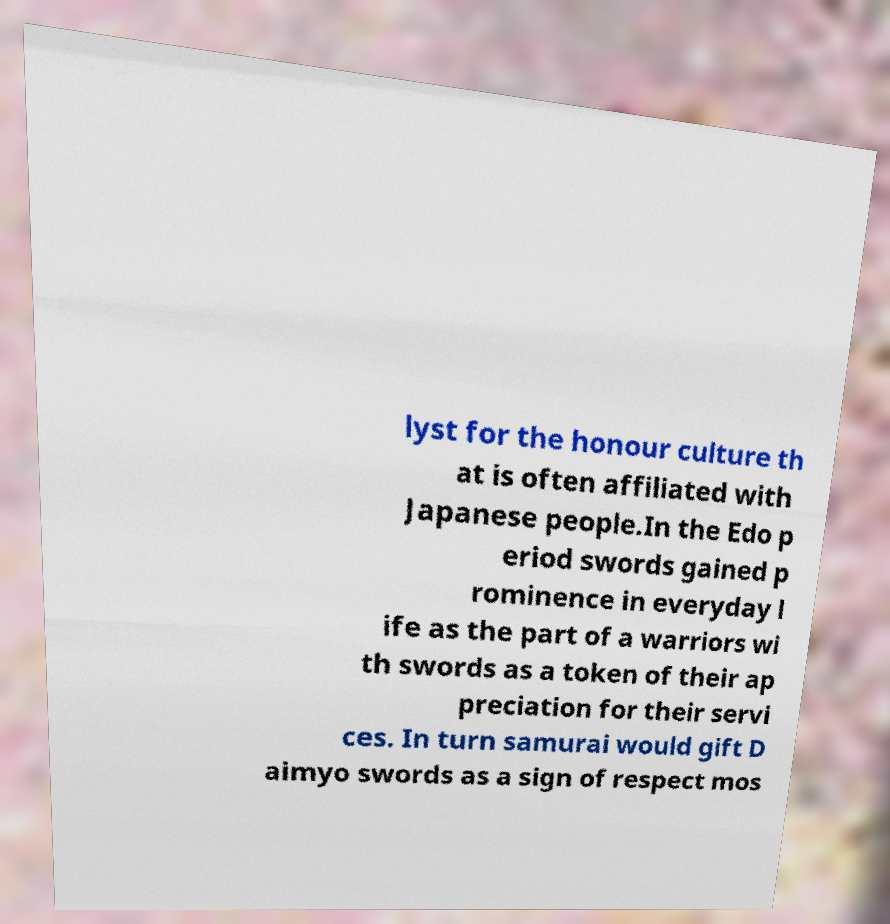Can you read and provide the text displayed in the image?This photo seems to have some interesting text. Can you extract and type it out for me? lyst for the honour culture th at is often affiliated with Japanese people.In the Edo p eriod swords gained p rominence in everyday l ife as the part of a warriors wi th swords as a token of their ap preciation for their servi ces. In turn samurai would gift D aimyo swords as a sign of respect mos 